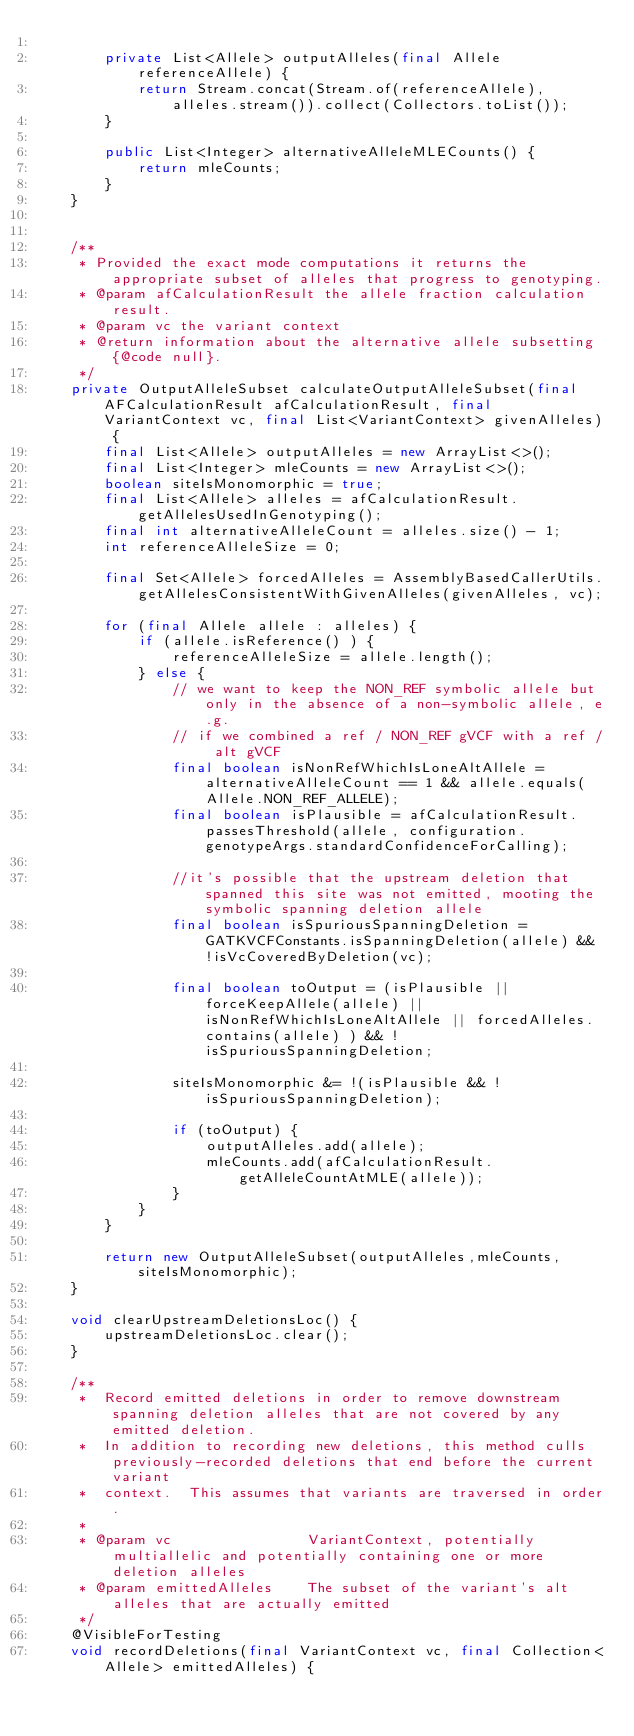<code> <loc_0><loc_0><loc_500><loc_500><_Java_>
        private List<Allele> outputAlleles(final Allele referenceAllele) {
            return Stream.concat(Stream.of(referenceAllele), alleles.stream()).collect(Collectors.toList());
        }

        public List<Integer> alternativeAlleleMLECounts() {
            return mleCounts;
        }
    }


    /**
     * Provided the exact mode computations it returns the appropriate subset of alleles that progress to genotyping.
     * @param afCalculationResult the allele fraction calculation result.
     * @param vc the variant context
     * @return information about the alternative allele subsetting {@code null}.
     */
    private OutputAlleleSubset calculateOutputAlleleSubset(final AFCalculationResult afCalculationResult, final VariantContext vc, final List<VariantContext> givenAlleles) {
        final List<Allele> outputAlleles = new ArrayList<>();
        final List<Integer> mleCounts = new ArrayList<>();
        boolean siteIsMonomorphic = true;
        final List<Allele> alleles = afCalculationResult.getAllelesUsedInGenotyping();
        final int alternativeAlleleCount = alleles.size() - 1;
        int referenceAlleleSize = 0;

        final Set<Allele> forcedAlleles = AssemblyBasedCallerUtils.getAllelesConsistentWithGivenAlleles(givenAlleles, vc);

        for (final Allele allele : alleles) {
            if (allele.isReference() ) {
                referenceAlleleSize = allele.length();
            } else {
                // we want to keep the NON_REF symbolic allele but only in the absence of a non-symbolic allele, e.g.
                // if we combined a ref / NON_REF gVCF with a ref / alt gVCF
                final boolean isNonRefWhichIsLoneAltAllele = alternativeAlleleCount == 1 && allele.equals(Allele.NON_REF_ALLELE);
                final boolean isPlausible = afCalculationResult.passesThreshold(allele, configuration.genotypeArgs.standardConfidenceForCalling);

                //it's possible that the upstream deletion that spanned this site was not emitted, mooting the symbolic spanning deletion allele
                final boolean isSpuriousSpanningDeletion = GATKVCFConstants.isSpanningDeletion(allele) && !isVcCoveredByDeletion(vc);

                final boolean toOutput = (isPlausible || forceKeepAllele(allele) || isNonRefWhichIsLoneAltAllele || forcedAlleles.contains(allele) ) && !isSpuriousSpanningDeletion;

                siteIsMonomorphic &= !(isPlausible && !isSpuriousSpanningDeletion);

                if (toOutput) {
                    outputAlleles.add(allele);
                    mleCounts.add(afCalculationResult.getAlleleCountAtMLE(allele));
                }
            }
        }

        return new OutputAlleleSubset(outputAlleles,mleCounts,siteIsMonomorphic);
    }

    void clearUpstreamDeletionsLoc() {
        upstreamDeletionsLoc.clear();
    }

    /**
     *  Record emitted deletions in order to remove downstream spanning deletion alleles that are not covered by any emitted deletion.
     *  In addition to recording new deletions, this method culls previously-recorded deletions that end before the current variant
     *  context.  This assumes that variants are traversed in order.
     *
     * @param vc                VariantContext, potentially multiallelic and potentially containing one or more deletion alleles
     * @param emittedAlleles    The subset of the variant's alt alleles that are actually emitted
     */
    @VisibleForTesting
    void recordDeletions(final VariantContext vc, final Collection<Allele> emittedAlleles) {</code> 